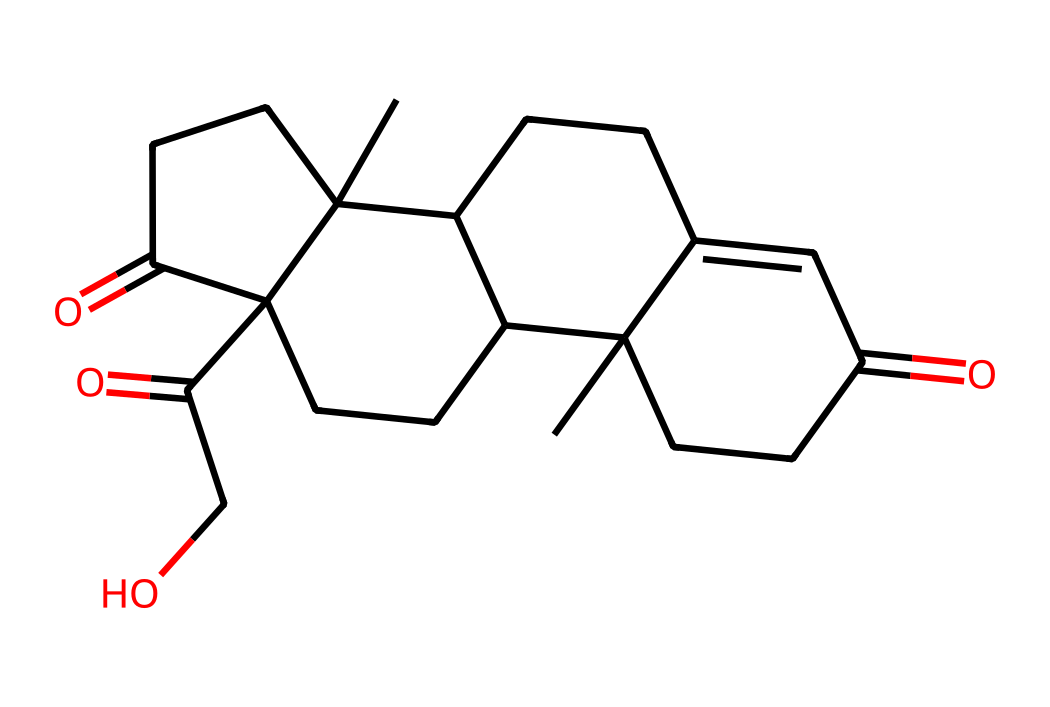What is the molecular formula of cortisol? By analyzing the SMILES representation, we can identify the individual atoms present. The structure includes carbon (C), hydrogen (H), and oxygen (O) atoms. Counting the atoms from the SMILES shows that there are 21 carbon atoms, 30 hydrogen atoms, and 5 oxygen atoms, giving the molecular formula: C21H30O5.
Answer: C21H30O5 How many rings are present in the structure of cortisol? Examining the structure indicated by the SMILES, we note the presence of multiple fused carbon rings which is characteristic of steroid hormones. The analysis reveals that there are four fused rings in cortisol's structure.
Answer: 4 What type of functional groups are present in cortisol? The SMILES demonstrates the presence of ketone (=O) and hydroxyl (–OH) functional groups in the structure. These groups can be identified by their unique notations in the SMILES. This indicates that cortisol has both ketone and alcohol functionalities.
Answer: ketone and alcohol What is the significance of the hydroxyl group in cortisol? The hydroxyl group (–OH) contributes to the polar characteristics of the molecule, affecting its solubility and participation in biochemical interactions, particularly in its role in mediating physiological effects. This specific functional group is crucial for the hormone's biological activity.
Answer: polar characteristics How does the structure of cortisol relate to its function as a stress hormone? The complex arrangement of carbon rings and functional groups, particularly the presence of the hydroxyl and ketone groups, influences cortisol's interaction with receptors in the body. This structural aspect facilitates cortisol's role in the stress response by regulating various physiological processes.
Answer: regulates stress response What is the IUPAC name of cortisol? To determine the IUPAC name, we need to analyze the structure indicated in the SMILES. The consensus for the chemical structure identifies cortisol as "21-hydroxy-11,17-dioxopregn-4-ene-3,20-dione." This is derived from its steroid framework and the functional groups present.
Answer: 21-hydroxy-11,17-dioxopregn-4-ene-3,20-dione 